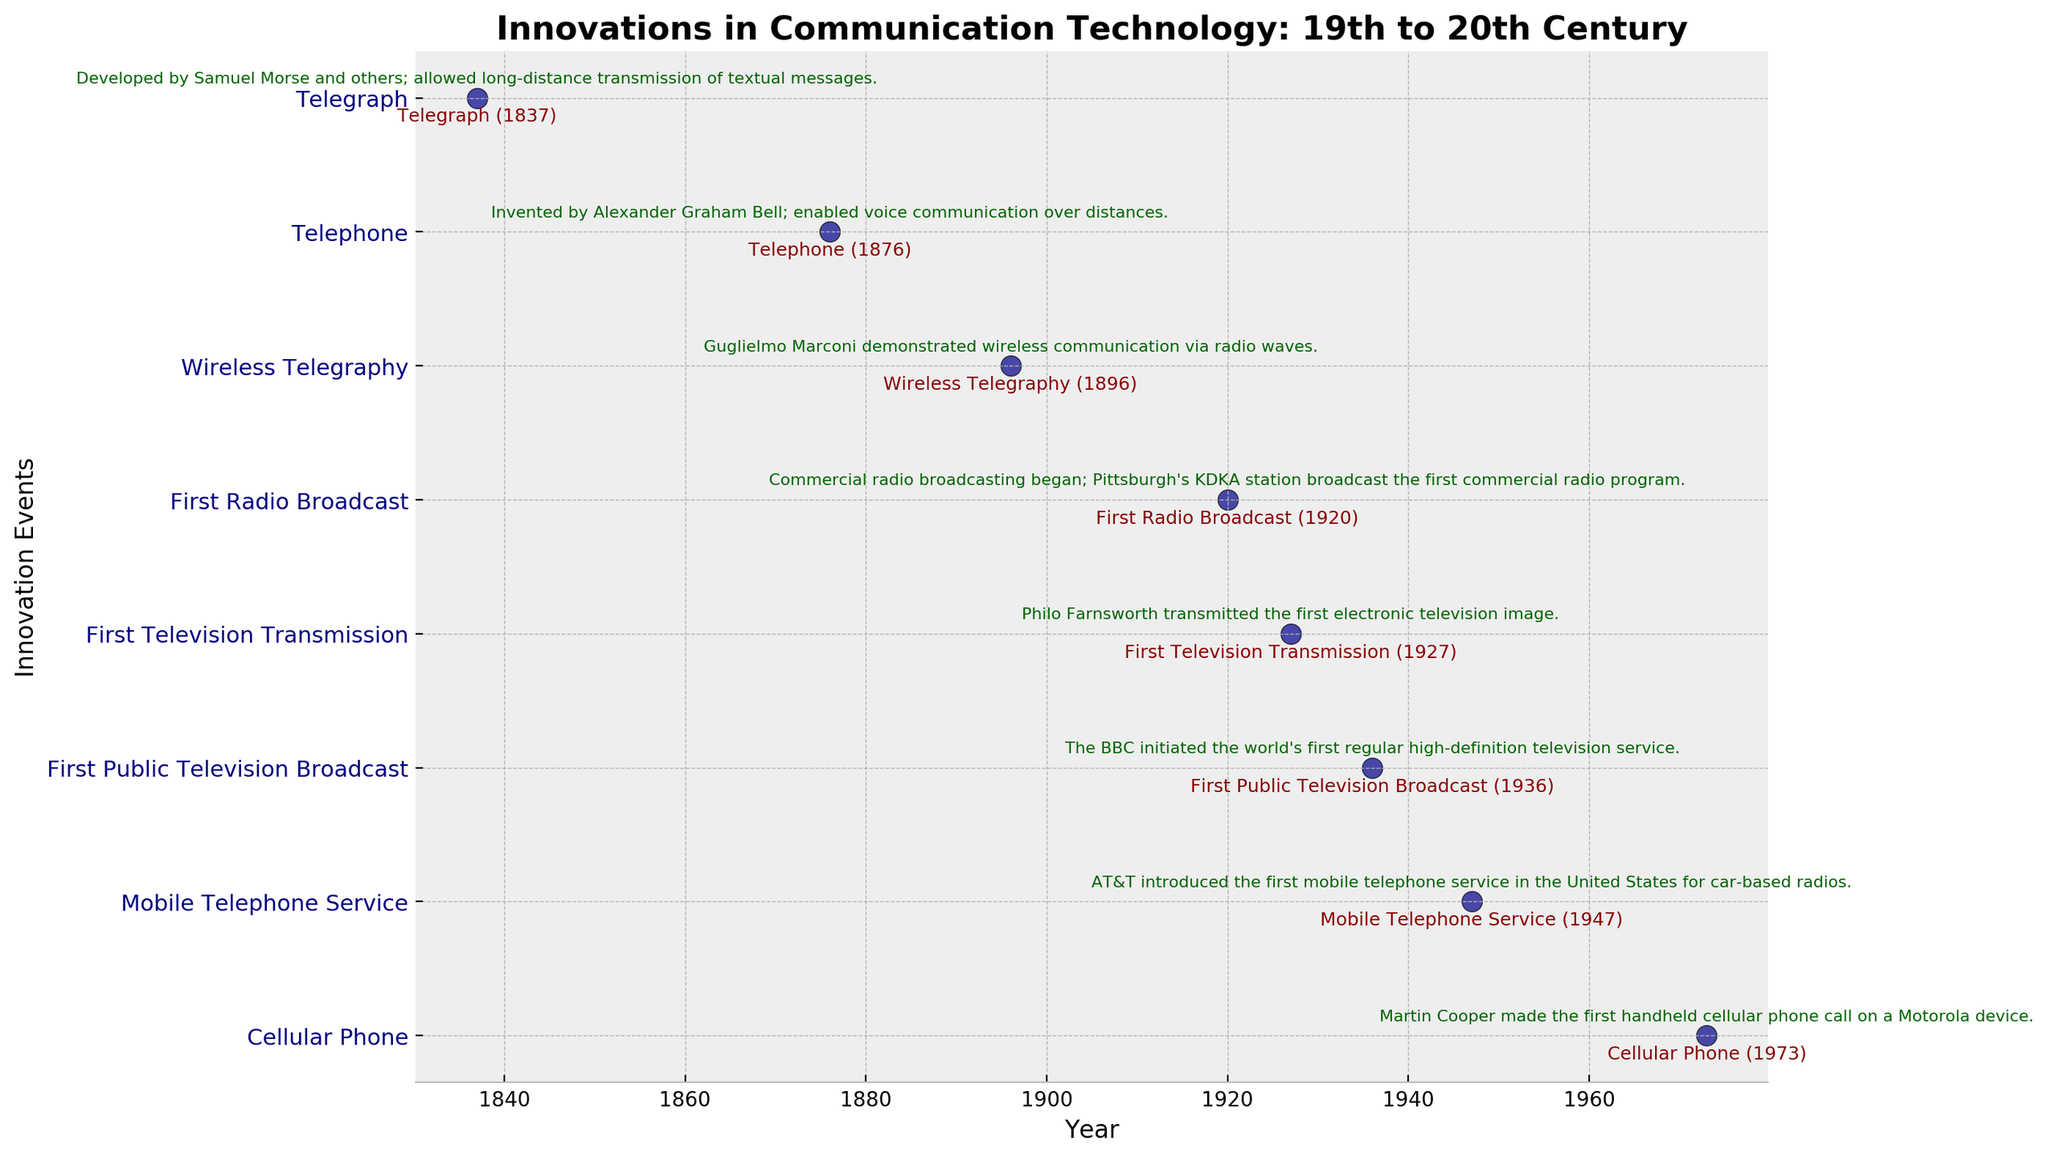Which innovation is depicted as having occurred in 1920? The year 1920 in the plot has an event labeled 'First Radio Broadcast' with a description of commercial radio broadcasting beginning at Pittsburgh's KDKA station.
Answer: First Radio Broadcast Which innovation was developed first according to the plot? The plot starts with the event in 1837, labeled 'Telegraph' with a description involving Samuel Morse's development.
Answer: Telegraph On what year was the first electronic television image transmitted according to the plot? By locating the event labeled 'First Television Transmission' on the plot, it corresponds to the year 1927.
Answer: 1927 How many communication technology innovations are listed from the 19th century according to the plot? There are two innovations plotted before the year 1900: 'Telegraph' in 1837 and 'Telephone' in 1876.
Answer: 2 What is the interval (in years) between the first radio broadcast and the first public television broadcast? 'First Radio Broadcast' occurred in 1920 while 'First Public Television Broadcast' happened in 1936. The interval is 1936 - 1920 which equals 16 years.
Answer: 16 years Which innovation came later, Wireless Telegraphy or Mobile Telephone Service? Wireless Telegraphy is marked in 1896 and Mobile Telephone Service in 1947, indicating that Mobile Telephone Service occurred later.
Answer: Mobile Telephone Service What innovation occurred exactly 50 years after the invention of the Telephone? 'Telephone' was invented in 1876. Fifty years later is 1926 but the closest event in the plot is 'First Television Transmission' in 1927.
Answer: First Television Transmission Compare and determine which has a shorter span between them: the distance from Teleported to Telephone or from Cellular Phone to Mobile Telephone Service? The interval between 'Telegraph' (1837) and 'Telephone' (1876) is 1876 - 1837 = 39 years. The interval between 'Mobile Telephone Service' (1947) and 'Cellular Phone' (1973) is 1973 - 1947 = 26 years. Thus, 'Cellular Phone' to 'Mobile Telephone Service' has a shorter span.
Answer: Cellular Phone to Mobile Telephone Service Calculate the average year of all innovations listed. Adding all the years ((1837 + 1876 + 1896 + 1920 + 1927 + 1936 + 1947 + 1973) = 14212) and dividing by the number of events (8) results in the average being 14212 / 8 = 1776.5.
Answer: 1776.5 